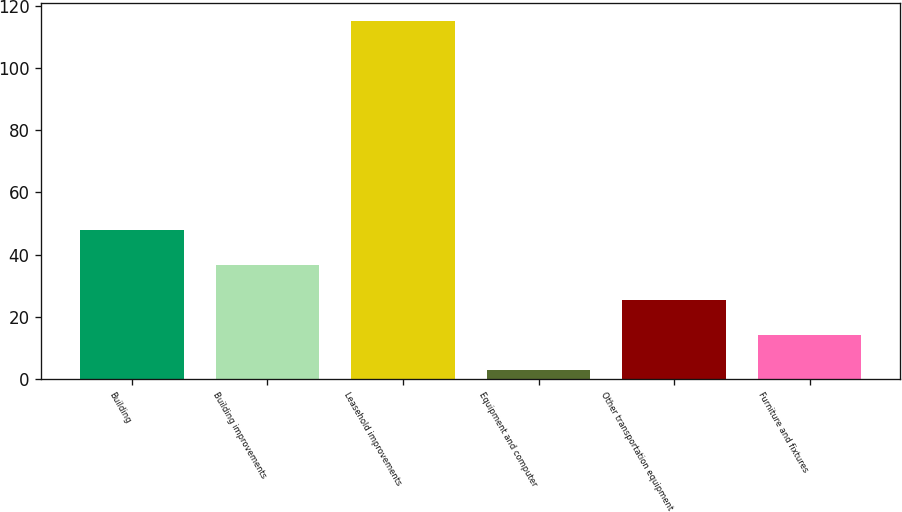Convert chart to OTSL. <chart><loc_0><loc_0><loc_500><loc_500><bar_chart><fcel>Building<fcel>Building improvements<fcel>Leasehold improvements<fcel>Equipment and computer<fcel>Other transportation equipment<fcel>Furniture and fixtures<nl><fcel>47.8<fcel>36.6<fcel>115<fcel>3<fcel>25.4<fcel>14.2<nl></chart> 